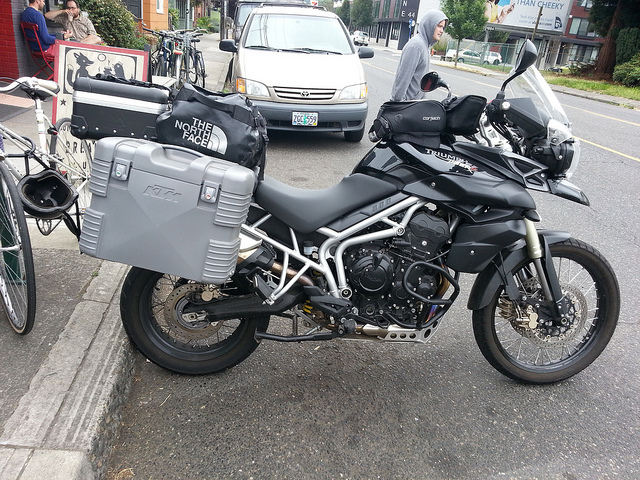Read all the text in this image. THE THE NORTH FACE FACE ZGC 559 CHEEKY HAN 44 U TRIUMPH 